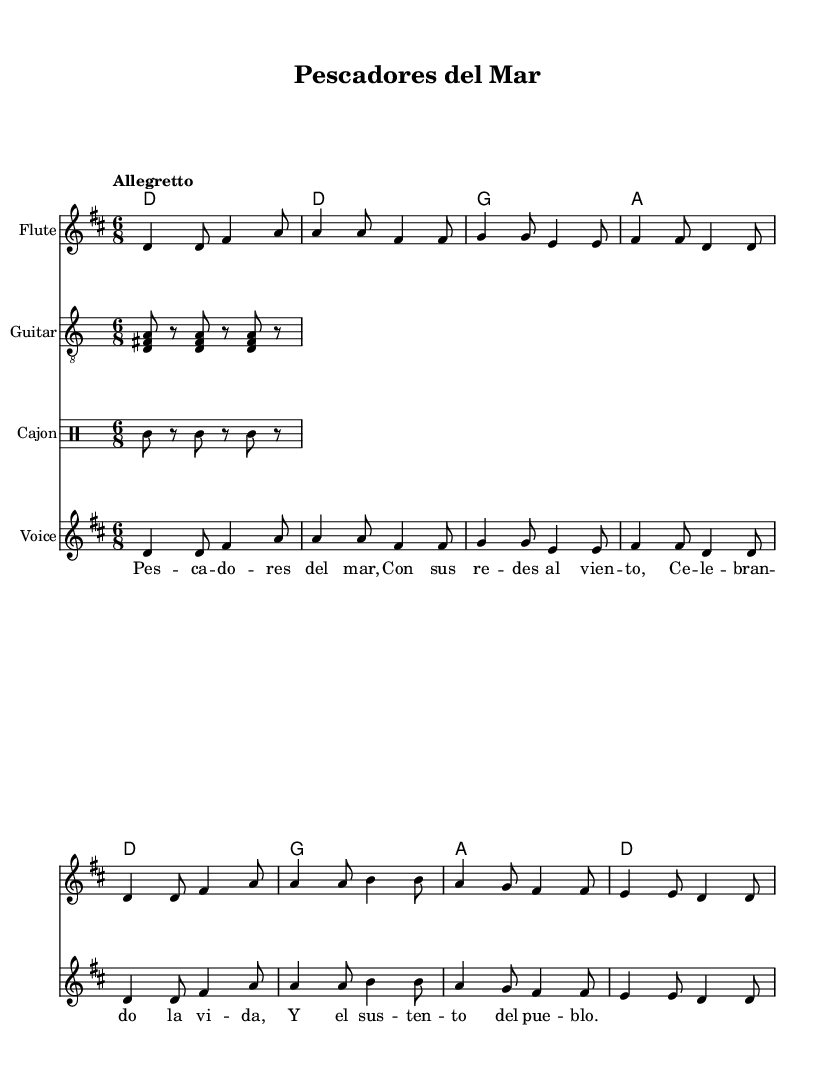What is the key signature of this music? The key signature is D major, which has two sharps (F# and C#). This can be determined from the key declaration in the global section of the code, which specifically states "\key d \major".
Answer: D major What is the time signature of the piece? The time signature is 6/8, which indicates that there are six eighth notes in each measure. This is evident from the notation "\time 6/8" in the global section of the code.
Answer: 6/8 What is the tempo marking of the piece? The tempo marking is Allegretto, which suggests a moderately fast tempo. This is indicated in the global section of the code where it states "\tempo 'Allegretto'".
Answer: Allegretto How many measures are in the melody? There are eight measures in the melody. By counting the number of complete groups of notes separated by vertical bar lines, we see a total of eight measures in the melody section.
Answer: 8 What instruments are included in the score? The instruments included are Flute, Guitar, Cajon, and Voice. This information is found in the score section where each instrument is labeled appropriately.
Answer: Flute, Guitar, Cajon, Voice What is the lyrical theme of the song? The lyrical theme celebrates fishermen and their way of life, referencing their work and connection to the sea and community. This is inferred from the translated lyrics in the verse section which mention "Pescadores del mar" (Fishermen of the Sea) and "el sustento del pueblo" (the sustenance of the village).
Answer: Celebration of fishermen 